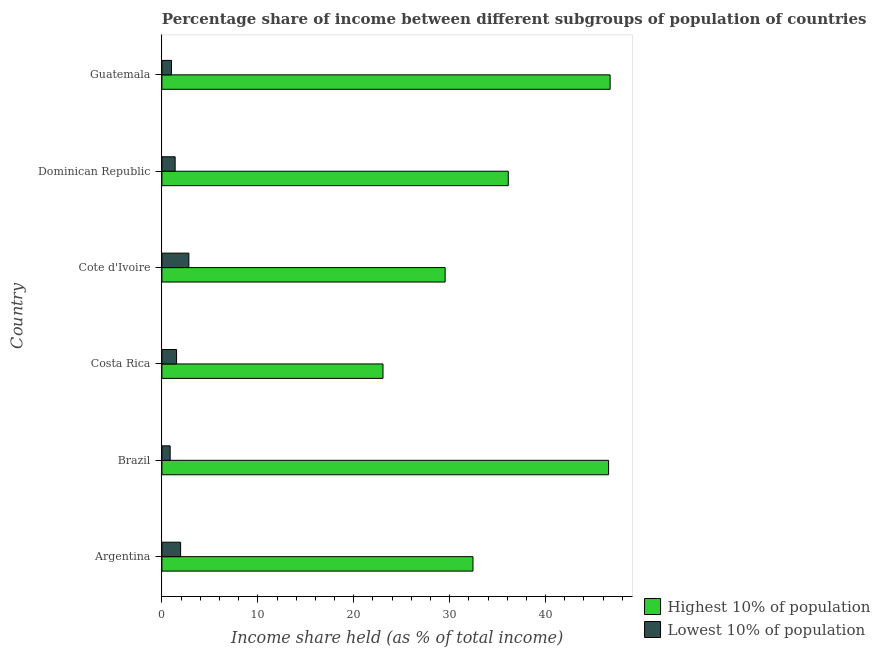How many different coloured bars are there?
Offer a terse response. 2. How many groups of bars are there?
Provide a succinct answer. 6. Are the number of bars on each tick of the Y-axis equal?
Your answer should be compact. Yes. What is the income share held by highest 10% of the population in Cote d'Ivoire?
Make the answer very short. 29.53. Across all countries, what is the maximum income share held by lowest 10% of the population?
Ensure brevity in your answer.  2.81. Across all countries, what is the minimum income share held by lowest 10% of the population?
Your answer should be very brief. 0.86. In which country was the income share held by lowest 10% of the population maximum?
Your answer should be compact. Cote d'Ivoire. In which country was the income share held by lowest 10% of the population minimum?
Your answer should be compact. Brazil. What is the total income share held by lowest 10% of the population in the graph?
Keep it short and to the point. 9.53. What is the difference between the income share held by lowest 10% of the population in Brazil and that in Costa Rica?
Make the answer very short. -0.67. What is the difference between the income share held by lowest 10% of the population in Guatemala and the income share held by highest 10% of the population in Dominican Republic?
Offer a very short reply. -35.11. What is the average income share held by highest 10% of the population per country?
Offer a very short reply. 35.74. What is the difference between the income share held by highest 10% of the population and income share held by lowest 10% of the population in Costa Rica?
Your answer should be compact. 21.52. What is the ratio of the income share held by lowest 10% of the population in Argentina to that in Costa Rica?
Make the answer very short. 1.27. What is the difference between the highest and the second highest income share held by highest 10% of the population?
Offer a very short reply. 0.16. What is the difference between the highest and the lowest income share held by lowest 10% of the population?
Your answer should be very brief. 1.95. In how many countries, is the income share held by highest 10% of the population greater than the average income share held by highest 10% of the population taken over all countries?
Offer a very short reply. 3. What does the 2nd bar from the top in Costa Rica represents?
Offer a very short reply. Highest 10% of population. What does the 1st bar from the bottom in Guatemala represents?
Make the answer very short. Highest 10% of population. Are all the bars in the graph horizontal?
Your answer should be compact. Yes. What is the difference between two consecutive major ticks on the X-axis?
Make the answer very short. 10. Does the graph contain any zero values?
Make the answer very short. No. What is the title of the graph?
Ensure brevity in your answer.  Percentage share of income between different subgroups of population of countries. Does "External balance on goods" appear as one of the legend labels in the graph?
Offer a terse response. No. What is the label or title of the X-axis?
Your answer should be very brief. Income share held (as % of total income). What is the Income share held (as % of total income) of Highest 10% of population in Argentina?
Provide a succinct answer. 32.43. What is the Income share held (as % of total income) of Lowest 10% of population in Argentina?
Offer a terse response. 1.95. What is the Income share held (as % of total income) of Highest 10% of population in Brazil?
Your answer should be very brief. 46.57. What is the Income share held (as % of total income) in Lowest 10% of population in Brazil?
Your answer should be compact. 0.86. What is the Income share held (as % of total income) in Highest 10% of population in Costa Rica?
Your answer should be compact. 23.05. What is the Income share held (as % of total income) of Lowest 10% of population in Costa Rica?
Make the answer very short. 1.53. What is the Income share held (as % of total income) in Highest 10% of population in Cote d'Ivoire?
Give a very brief answer. 29.53. What is the Income share held (as % of total income) in Lowest 10% of population in Cote d'Ivoire?
Your answer should be compact. 2.81. What is the Income share held (as % of total income) of Highest 10% of population in Dominican Republic?
Your answer should be compact. 36.11. What is the Income share held (as % of total income) in Lowest 10% of population in Dominican Republic?
Your answer should be compact. 1.38. What is the Income share held (as % of total income) of Highest 10% of population in Guatemala?
Ensure brevity in your answer.  46.73. Across all countries, what is the maximum Income share held (as % of total income) of Highest 10% of population?
Offer a terse response. 46.73. Across all countries, what is the maximum Income share held (as % of total income) in Lowest 10% of population?
Provide a succinct answer. 2.81. Across all countries, what is the minimum Income share held (as % of total income) in Highest 10% of population?
Make the answer very short. 23.05. Across all countries, what is the minimum Income share held (as % of total income) of Lowest 10% of population?
Your answer should be compact. 0.86. What is the total Income share held (as % of total income) of Highest 10% of population in the graph?
Give a very brief answer. 214.42. What is the total Income share held (as % of total income) of Lowest 10% of population in the graph?
Make the answer very short. 9.53. What is the difference between the Income share held (as % of total income) in Highest 10% of population in Argentina and that in Brazil?
Keep it short and to the point. -14.14. What is the difference between the Income share held (as % of total income) in Lowest 10% of population in Argentina and that in Brazil?
Offer a terse response. 1.09. What is the difference between the Income share held (as % of total income) in Highest 10% of population in Argentina and that in Costa Rica?
Give a very brief answer. 9.38. What is the difference between the Income share held (as % of total income) in Lowest 10% of population in Argentina and that in Costa Rica?
Provide a short and direct response. 0.42. What is the difference between the Income share held (as % of total income) in Highest 10% of population in Argentina and that in Cote d'Ivoire?
Make the answer very short. 2.9. What is the difference between the Income share held (as % of total income) of Lowest 10% of population in Argentina and that in Cote d'Ivoire?
Your response must be concise. -0.86. What is the difference between the Income share held (as % of total income) in Highest 10% of population in Argentina and that in Dominican Republic?
Make the answer very short. -3.68. What is the difference between the Income share held (as % of total income) of Lowest 10% of population in Argentina and that in Dominican Republic?
Provide a short and direct response. 0.57. What is the difference between the Income share held (as % of total income) of Highest 10% of population in Argentina and that in Guatemala?
Make the answer very short. -14.3. What is the difference between the Income share held (as % of total income) in Highest 10% of population in Brazil and that in Costa Rica?
Your response must be concise. 23.52. What is the difference between the Income share held (as % of total income) of Lowest 10% of population in Brazil and that in Costa Rica?
Ensure brevity in your answer.  -0.67. What is the difference between the Income share held (as % of total income) of Highest 10% of population in Brazil and that in Cote d'Ivoire?
Your answer should be compact. 17.04. What is the difference between the Income share held (as % of total income) in Lowest 10% of population in Brazil and that in Cote d'Ivoire?
Keep it short and to the point. -1.95. What is the difference between the Income share held (as % of total income) of Highest 10% of population in Brazil and that in Dominican Republic?
Keep it short and to the point. 10.46. What is the difference between the Income share held (as % of total income) of Lowest 10% of population in Brazil and that in Dominican Republic?
Offer a terse response. -0.52. What is the difference between the Income share held (as % of total income) in Highest 10% of population in Brazil and that in Guatemala?
Your answer should be very brief. -0.16. What is the difference between the Income share held (as % of total income) of Lowest 10% of population in Brazil and that in Guatemala?
Keep it short and to the point. -0.14. What is the difference between the Income share held (as % of total income) of Highest 10% of population in Costa Rica and that in Cote d'Ivoire?
Offer a terse response. -6.48. What is the difference between the Income share held (as % of total income) of Lowest 10% of population in Costa Rica and that in Cote d'Ivoire?
Give a very brief answer. -1.28. What is the difference between the Income share held (as % of total income) of Highest 10% of population in Costa Rica and that in Dominican Republic?
Give a very brief answer. -13.06. What is the difference between the Income share held (as % of total income) in Highest 10% of population in Costa Rica and that in Guatemala?
Offer a terse response. -23.68. What is the difference between the Income share held (as % of total income) in Lowest 10% of population in Costa Rica and that in Guatemala?
Your answer should be very brief. 0.53. What is the difference between the Income share held (as % of total income) in Highest 10% of population in Cote d'Ivoire and that in Dominican Republic?
Your response must be concise. -6.58. What is the difference between the Income share held (as % of total income) of Lowest 10% of population in Cote d'Ivoire and that in Dominican Republic?
Offer a terse response. 1.43. What is the difference between the Income share held (as % of total income) in Highest 10% of population in Cote d'Ivoire and that in Guatemala?
Make the answer very short. -17.2. What is the difference between the Income share held (as % of total income) in Lowest 10% of population in Cote d'Ivoire and that in Guatemala?
Your answer should be very brief. 1.81. What is the difference between the Income share held (as % of total income) of Highest 10% of population in Dominican Republic and that in Guatemala?
Keep it short and to the point. -10.62. What is the difference between the Income share held (as % of total income) in Lowest 10% of population in Dominican Republic and that in Guatemala?
Keep it short and to the point. 0.38. What is the difference between the Income share held (as % of total income) of Highest 10% of population in Argentina and the Income share held (as % of total income) of Lowest 10% of population in Brazil?
Offer a very short reply. 31.57. What is the difference between the Income share held (as % of total income) of Highest 10% of population in Argentina and the Income share held (as % of total income) of Lowest 10% of population in Costa Rica?
Provide a short and direct response. 30.9. What is the difference between the Income share held (as % of total income) in Highest 10% of population in Argentina and the Income share held (as % of total income) in Lowest 10% of population in Cote d'Ivoire?
Give a very brief answer. 29.62. What is the difference between the Income share held (as % of total income) of Highest 10% of population in Argentina and the Income share held (as % of total income) of Lowest 10% of population in Dominican Republic?
Your response must be concise. 31.05. What is the difference between the Income share held (as % of total income) of Highest 10% of population in Argentina and the Income share held (as % of total income) of Lowest 10% of population in Guatemala?
Your response must be concise. 31.43. What is the difference between the Income share held (as % of total income) of Highest 10% of population in Brazil and the Income share held (as % of total income) of Lowest 10% of population in Costa Rica?
Make the answer very short. 45.04. What is the difference between the Income share held (as % of total income) of Highest 10% of population in Brazil and the Income share held (as % of total income) of Lowest 10% of population in Cote d'Ivoire?
Offer a very short reply. 43.76. What is the difference between the Income share held (as % of total income) of Highest 10% of population in Brazil and the Income share held (as % of total income) of Lowest 10% of population in Dominican Republic?
Offer a terse response. 45.19. What is the difference between the Income share held (as % of total income) in Highest 10% of population in Brazil and the Income share held (as % of total income) in Lowest 10% of population in Guatemala?
Your response must be concise. 45.57. What is the difference between the Income share held (as % of total income) in Highest 10% of population in Costa Rica and the Income share held (as % of total income) in Lowest 10% of population in Cote d'Ivoire?
Your answer should be compact. 20.24. What is the difference between the Income share held (as % of total income) of Highest 10% of population in Costa Rica and the Income share held (as % of total income) of Lowest 10% of population in Dominican Republic?
Offer a very short reply. 21.67. What is the difference between the Income share held (as % of total income) in Highest 10% of population in Costa Rica and the Income share held (as % of total income) in Lowest 10% of population in Guatemala?
Give a very brief answer. 22.05. What is the difference between the Income share held (as % of total income) of Highest 10% of population in Cote d'Ivoire and the Income share held (as % of total income) of Lowest 10% of population in Dominican Republic?
Give a very brief answer. 28.15. What is the difference between the Income share held (as % of total income) of Highest 10% of population in Cote d'Ivoire and the Income share held (as % of total income) of Lowest 10% of population in Guatemala?
Provide a succinct answer. 28.53. What is the difference between the Income share held (as % of total income) of Highest 10% of population in Dominican Republic and the Income share held (as % of total income) of Lowest 10% of population in Guatemala?
Provide a succinct answer. 35.11. What is the average Income share held (as % of total income) of Highest 10% of population per country?
Make the answer very short. 35.74. What is the average Income share held (as % of total income) of Lowest 10% of population per country?
Provide a short and direct response. 1.59. What is the difference between the Income share held (as % of total income) in Highest 10% of population and Income share held (as % of total income) in Lowest 10% of population in Argentina?
Offer a very short reply. 30.48. What is the difference between the Income share held (as % of total income) of Highest 10% of population and Income share held (as % of total income) of Lowest 10% of population in Brazil?
Keep it short and to the point. 45.71. What is the difference between the Income share held (as % of total income) of Highest 10% of population and Income share held (as % of total income) of Lowest 10% of population in Costa Rica?
Your response must be concise. 21.52. What is the difference between the Income share held (as % of total income) of Highest 10% of population and Income share held (as % of total income) of Lowest 10% of population in Cote d'Ivoire?
Your response must be concise. 26.72. What is the difference between the Income share held (as % of total income) of Highest 10% of population and Income share held (as % of total income) of Lowest 10% of population in Dominican Republic?
Your answer should be very brief. 34.73. What is the difference between the Income share held (as % of total income) in Highest 10% of population and Income share held (as % of total income) in Lowest 10% of population in Guatemala?
Your answer should be compact. 45.73. What is the ratio of the Income share held (as % of total income) in Highest 10% of population in Argentina to that in Brazil?
Your response must be concise. 0.7. What is the ratio of the Income share held (as % of total income) of Lowest 10% of population in Argentina to that in Brazil?
Offer a terse response. 2.27. What is the ratio of the Income share held (as % of total income) in Highest 10% of population in Argentina to that in Costa Rica?
Offer a terse response. 1.41. What is the ratio of the Income share held (as % of total income) in Lowest 10% of population in Argentina to that in Costa Rica?
Make the answer very short. 1.27. What is the ratio of the Income share held (as % of total income) of Highest 10% of population in Argentina to that in Cote d'Ivoire?
Keep it short and to the point. 1.1. What is the ratio of the Income share held (as % of total income) in Lowest 10% of population in Argentina to that in Cote d'Ivoire?
Your response must be concise. 0.69. What is the ratio of the Income share held (as % of total income) of Highest 10% of population in Argentina to that in Dominican Republic?
Your answer should be compact. 0.9. What is the ratio of the Income share held (as % of total income) of Lowest 10% of population in Argentina to that in Dominican Republic?
Ensure brevity in your answer.  1.41. What is the ratio of the Income share held (as % of total income) in Highest 10% of population in Argentina to that in Guatemala?
Your answer should be compact. 0.69. What is the ratio of the Income share held (as % of total income) in Lowest 10% of population in Argentina to that in Guatemala?
Ensure brevity in your answer.  1.95. What is the ratio of the Income share held (as % of total income) in Highest 10% of population in Brazil to that in Costa Rica?
Your answer should be compact. 2.02. What is the ratio of the Income share held (as % of total income) of Lowest 10% of population in Brazil to that in Costa Rica?
Offer a terse response. 0.56. What is the ratio of the Income share held (as % of total income) of Highest 10% of population in Brazil to that in Cote d'Ivoire?
Give a very brief answer. 1.58. What is the ratio of the Income share held (as % of total income) of Lowest 10% of population in Brazil to that in Cote d'Ivoire?
Provide a succinct answer. 0.31. What is the ratio of the Income share held (as % of total income) of Highest 10% of population in Brazil to that in Dominican Republic?
Provide a short and direct response. 1.29. What is the ratio of the Income share held (as % of total income) in Lowest 10% of population in Brazil to that in Dominican Republic?
Provide a short and direct response. 0.62. What is the ratio of the Income share held (as % of total income) in Lowest 10% of population in Brazil to that in Guatemala?
Your answer should be compact. 0.86. What is the ratio of the Income share held (as % of total income) of Highest 10% of population in Costa Rica to that in Cote d'Ivoire?
Your answer should be very brief. 0.78. What is the ratio of the Income share held (as % of total income) in Lowest 10% of population in Costa Rica to that in Cote d'Ivoire?
Your response must be concise. 0.54. What is the ratio of the Income share held (as % of total income) in Highest 10% of population in Costa Rica to that in Dominican Republic?
Give a very brief answer. 0.64. What is the ratio of the Income share held (as % of total income) of Lowest 10% of population in Costa Rica to that in Dominican Republic?
Offer a terse response. 1.11. What is the ratio of the Income share held (as % of total income) of Highest 10% of population in Costa Rica to that in Guatemala?
Give a very brief answer. 0.49. What is the ratio of the Income share held (as % of total income) of Lowest 10% of population in Costa Rica to that in Guatemala?
Offer a terse response. 1.53. What is the ratio of the Income share held (as % of total income) in Highest 10% of population in Cote d'Ivoire to that in Dominican Republic?
Offer a terse response. 0.82. What is the ratio of the Income share held (as % of total income) of Lowest 10% of population in Cote d'Ivoire to that in Dominican Republic?
Ensure brevity in your answer.  2.04. What is the ratio of the Income share held (as % of total income) in Highest 10% of population in Cote d'Ivoire to that in Guatemala?
Provide a short and direct response. 0.63. What is the ratio of the Income share held (as % of total income) in Lowest 10% of population in Cote d'Ivoire to that in Guatemala?
Your answer should be very brief. 2.81. What is the ratio of the Income share held (as % of total income) in Highest 10% of population in Dominican Republic to that in Guatemala?
Provide a short and direct response. 0.77. What is the ratio of the Income share held (as % of total income) in Lowest 10% of population in Dominican Republic to that in Guatemala?
Provide a succinct answer. 1.38. What is the difference between the highest and the second highest Income share held (as % of total income) of Highest 10% of population?
Keep it short and to the point. 0.16. What is the difference between the highest and the second highest Income share held (as % of total income) of Lowest 10% of population?
Give a very brief answer. 0.86. What is the difference between the highest and the lowest Income share held (as % of total income) in Highest 10% of population?
Your answer should be compact. 23.68. What is the difference between the highest and the lowest Income share held (as % of total income) of Lowest 10% of population?
Keep it short and to the point. 1.95. 